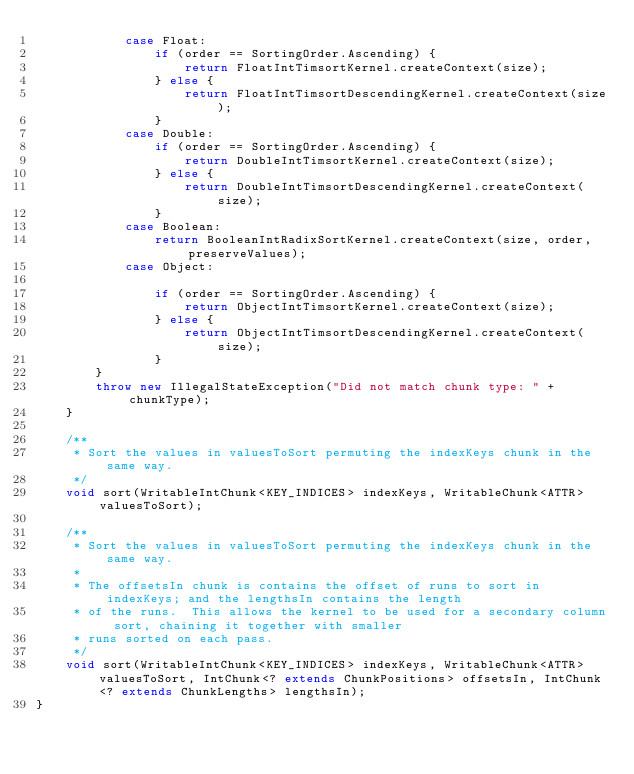Convert code to text. <code><loc_0><loc_0><loc_500><loc_500><_Java_>            case Float:
                if (order == SortingOrder.Ascending) {
                    return FloatIntTimsortKernel.createContext(size);
                } else {
                    return FloatIntTimsortDescendingKernel.createContext(size);
                }
            case Double:
                if (order == SortingOrder.Ascending) {
                    return DoubleIntTimsortKernel.createContext(size);
                } else {
                    return DoubleIntTimsortDescendingKernel.createContext(size);
                }
            case Boolean:
                return BooleanIntRadixSortKernel.createContext(size, order, preserveValues);
            case Object:

                if (order == SortingOrder.Ascending) {
                    return ObjectIntTimsortKernel.createContext(size);
                } else {
                    return ObjectIntTimsortDescendingKernel.createContext(size);
                }
        }
        throw new IllegalStateException("Did not match chunk type: " + chunkType);
    }

    /**
     * Sort the values in valuesToSort permuting the indexKeys chunk in the same way.
     */
    void sort(WritableIntChunk<KEY_INDICES> indexKeys, WritableChunk<ATTR> valuesToSort);

    /**
     * Sort the values in valuesToSort permuting the indexKeys chunk in the same way.
     *
     * The offsetsIn chunk is contains the offset of runs to sort in indexKeys; and the lengthsIn contains the length
     * of the runs.  This allows the kernel to be used for a secondary column sort, chaining it together with smaller
     * runs sorted on each pass.
     */
    void sort(WritableIntChunk<KEY_INDICES> indexKeys, WritableChunk<ATTR> valuesToSort, IntChunk<? extends ChunkPositions> offsetsIn, IntChunk<? extends ChunkLengths> lengthsIn);
}
</code> 